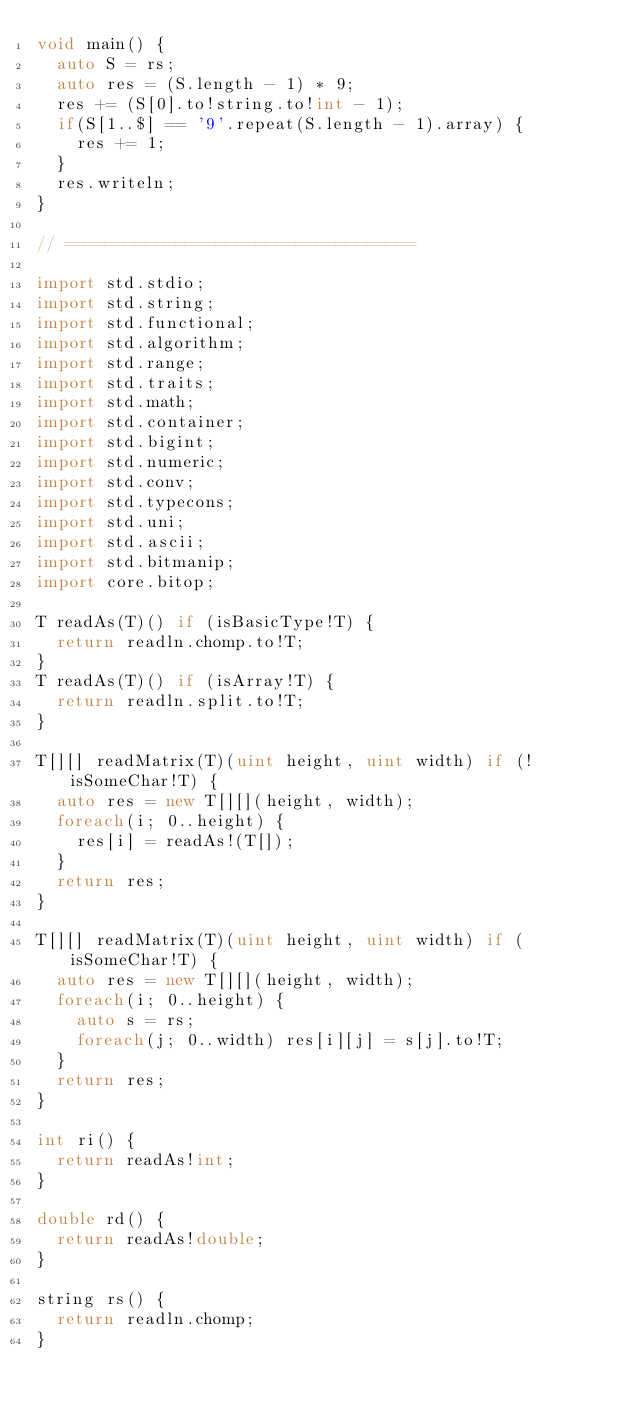Convert code to text. <code><loc_0><loc_0><loc_500><loc_500><_D_>void main() {
	auto S = rs;
	auto res = (S.length - 1) * 9;
	res += (S[0].to!string.to!int - 1);
	if(S[1..$] == '9'.repeat(S.length - 1).array) {
		res += 1;
	}
	res.writeln;
}

// ===================================

import std.stdio;
import std.string;
import std.functional;
import std.algorithm;
import std.range;
import std.traits;
import std.math;
import std.container;
import std.bigint;
import std.numeric;
import std.conv;
import std.typecons;
import std.uni;
import std.ascii;
import std.bitmanip;
import core.bitop;

T readAs(T)() if (isBasicType!T) {
	return readln.chomp.to!T;
}
T readAs(T)() if (isArray!T) {
	return readln.split.to!T;
}

T[][] readMatrix(T)(uint height, uint width) if (!isSomeChar!T) {
	auto res = new T[][](height, width);
	foreach(i; 0..height) {
		res[i] = readAs!(T[]);
	}
	return res;
}

T[][] readMatrix(T)(uint height, uint width) if (isSomeChar!T) {
	auto res = new T[][](height, width);
	foreach(i; 0..height) {
		auto s = rs;
		foreach(j; 0..width) res[i][j] = s[j].to!T;
	}
	return res;
}

int ri() {
	return readAs!int;
}

double rd() {
	return readAs!double;
}

string rs() {
	return readln.chomp;
}
</code> 